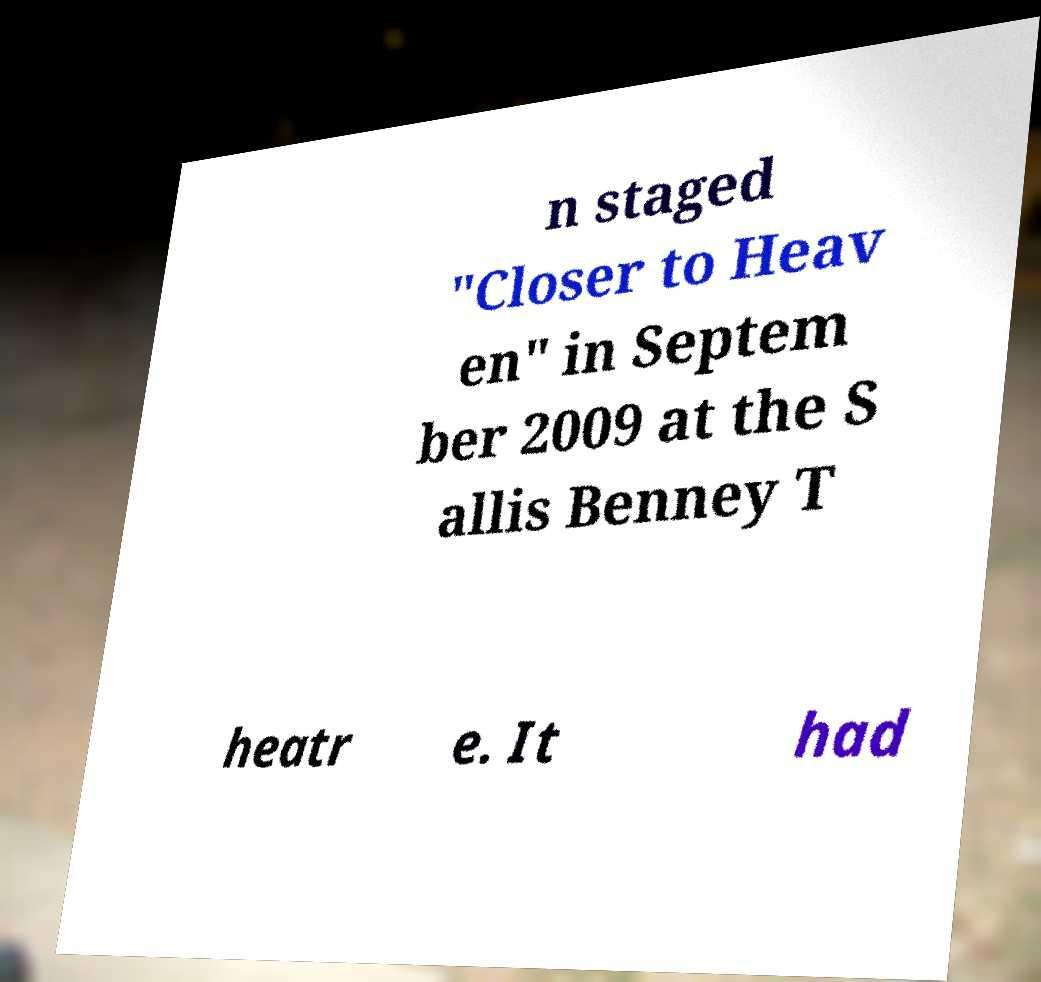I need the written content from this picture converted into text. Can you do that? n staged "Closer to Heav en" in Septem ber 2009 at the S allis Benney T heatr e. It had 